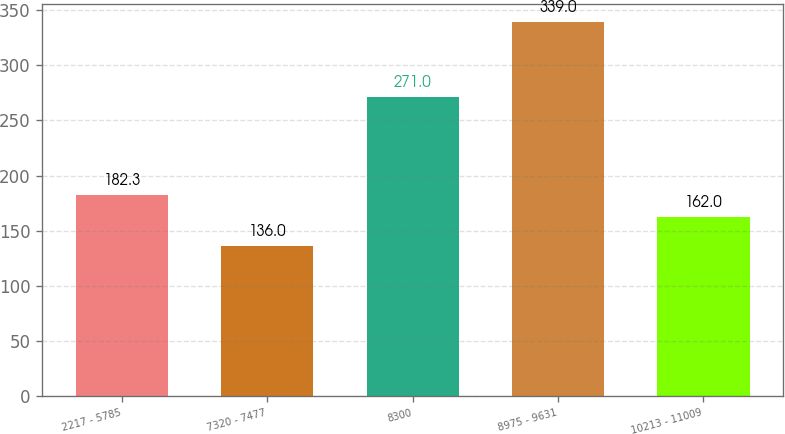Convert chart. <chart><loc_0><loc_0><loc_500><loc_500><bar_chart><fcel>2217 - 5785<fcel>7320 - 7477<fcel>8300<fcel>8975 - 9631<fcel>10213 - 11009<nl><fcel>182.3<fcel>136<fcel>271<fcel>339<fcel>162<nl></chart> 